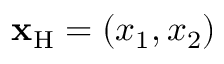<formula> <loc_0><loc_0><loc_500><loc_500>{ x } _ { H } = ( x _ { 1 } , x _ { 2 } )</formula> 